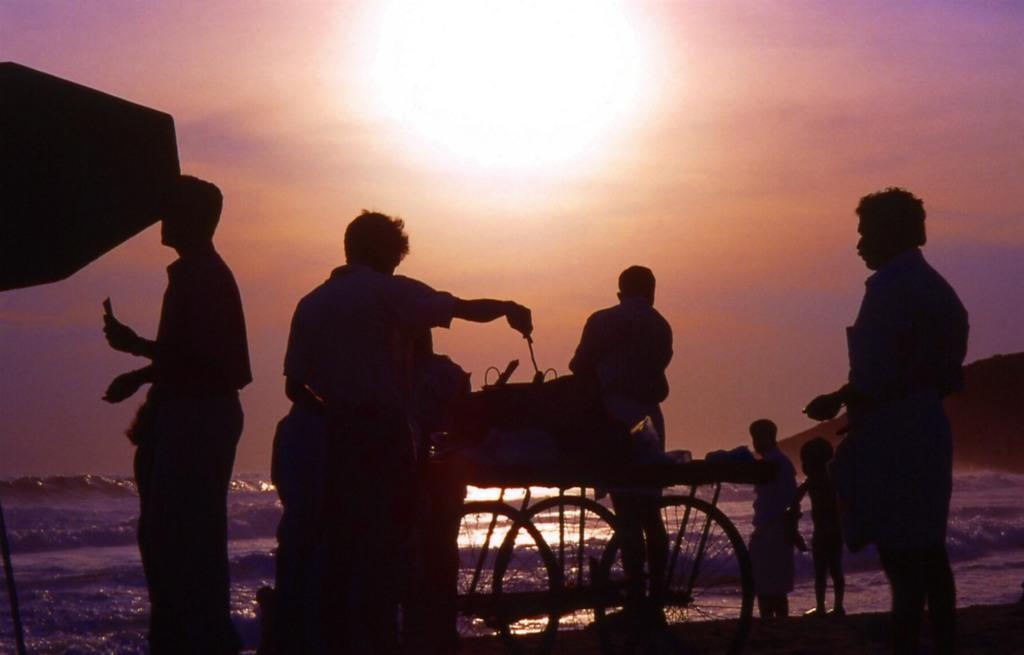Could you give a brief overview of what you see in this image? This picture shows few people standing and we see a cart and we see a man cooking on it and we see water and sunlight in the sky. 